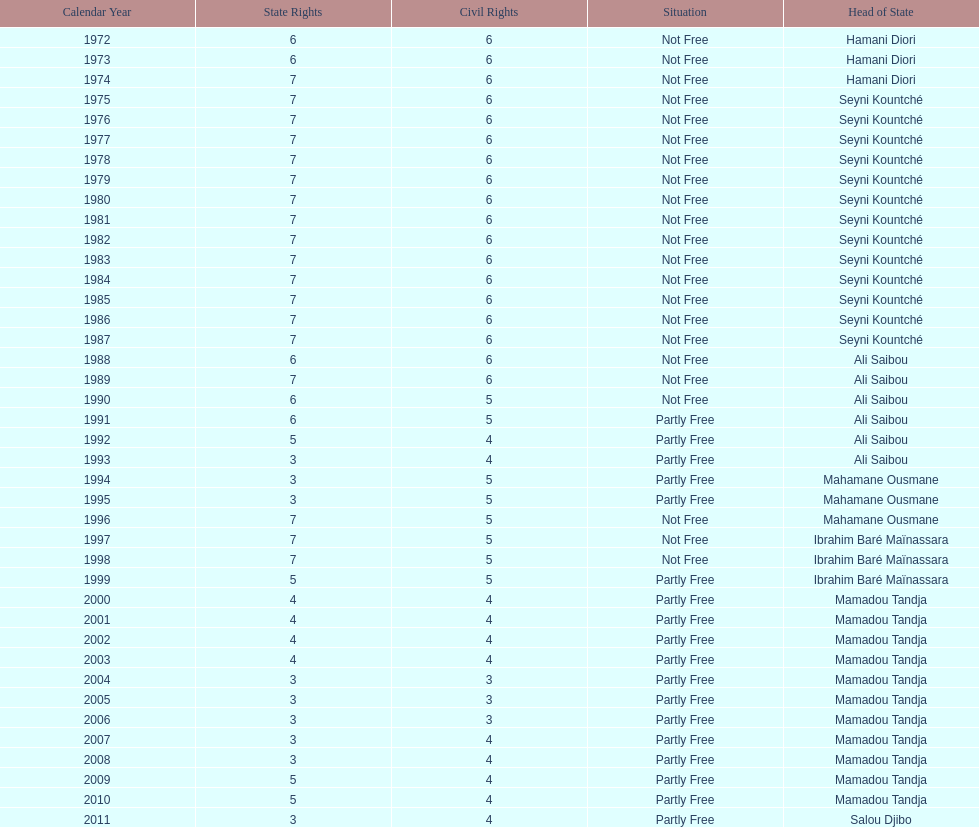Could you parse the entire table? {'header': ['Calendar Year', 'State Rights', 'Civil Rights', 'Situation', 'Head of State'], 'rows': [['1972', '6', '6', 'Not Free', 'Hamani Diori'], ['1973', '6', '6', 'Not Free', 'Hamani Diori'], ['1974', '7', '6', 'Not Free', 'Hamani Diori'], ['1975', '7', '6', 'Not Free', 'Seyni Kountché'], ['1976', '7', '6', 'Not Free', 'Seyni Kountché'], ['1977', '7', '6', 'Not Free', 'Seyni Kountché'], ['1978', '7', '6', 'Not Free', 'Seyni Kountché'], ['1979', '7', '6', 'Not Free', 'Seyni Kountché'], ['1980', '7', '6', 'Not Free', 'Seyni Kountché'], ['1981', '7', '6', 'Not Free', 'Seyni Kountché'], ['1982', '7', '6', 'Not Free', 'Seyni Kountché'], ['1983', '7', '6', 'Not Free', 'Seyni Kountché'], ['1984', '7', '6', 'Not Free', 'Seyni Kountché'], ['1985', '7', '6', 'Not Free', 'Seyni Kountché'], ['1986', '7', '6', 'Not Free', 'Seyni Kountché'], ['1987', '7', '6', 'Not Free', 'Seyni Kountché'], ['1988', '6', '6', 'Not Free', 'Ali Saibou'], ['1989', '7', '6', 'Not Free', 'Ali Saibou'], ['1990', '6', '5', 'Not Free', 'Ali Saibou'], ['1991', '6', '5', 'Partly Free', 'Ali Saibou'], ['1992', '5', '4', 'Partly Free', 'Ali Saibou'], ['1993', '3', '4', 'Partly Free', 'Ali Saibou'], ['1994', '3', '5', 'Partly Free', 'Mahamane Ousmane'], ['1995', '3', '5', 'Partly Free', 'Mahamane Ousmane'], ['1996', '7', '5', 'Not Free', 'Mahamane Ousmane'], ['1997', '7', '5', 'Not Free', 'Ibrahim Baré Maïnassara'], ['1998', '7', '5', 'Not Free', 'Ibrahim Baré Maïnassara'], ['1999', '5', '5', 'Partly Free', 'Ibrahim Baré Maïnassara'], ['2000', '4', '4', 'Partly Free', 'Mamadou Tandja'], ['2001', '4', '4', 'Partly Free', 'Mamadou Tandja'], ['2002', '4', '4', 'Partly Free', 'Mamadou Tandja'], ['2003', '4', '4', 'Partly Free', 'Mamadou Tandja'], ['2004', '3', '3', 'Partly Free', 'Mamadou Tandja'], ['2005', '3', '3', 'Partly Free', 'Mamadou Tandja'], ['2006', '3', '3', 'Partly Free', 'Mamadou Tandja'], ['2007', '3', '4', 'Partly Free', 'Mamadou Tandja'], ['2008', '3', '4', 'Partly Free', 'Mamadou Tandja'], ['2009', '5', '4', 'Partly Free', 'Mamadou Tandja'], ['2010', '5', '4', 'Partly Free', 'Mamadou Tandja'], ['2011', '3', '4', 'Partly Free', 'Salou Djibo']]} What is the number of time seyni kountche has been president? 13. 